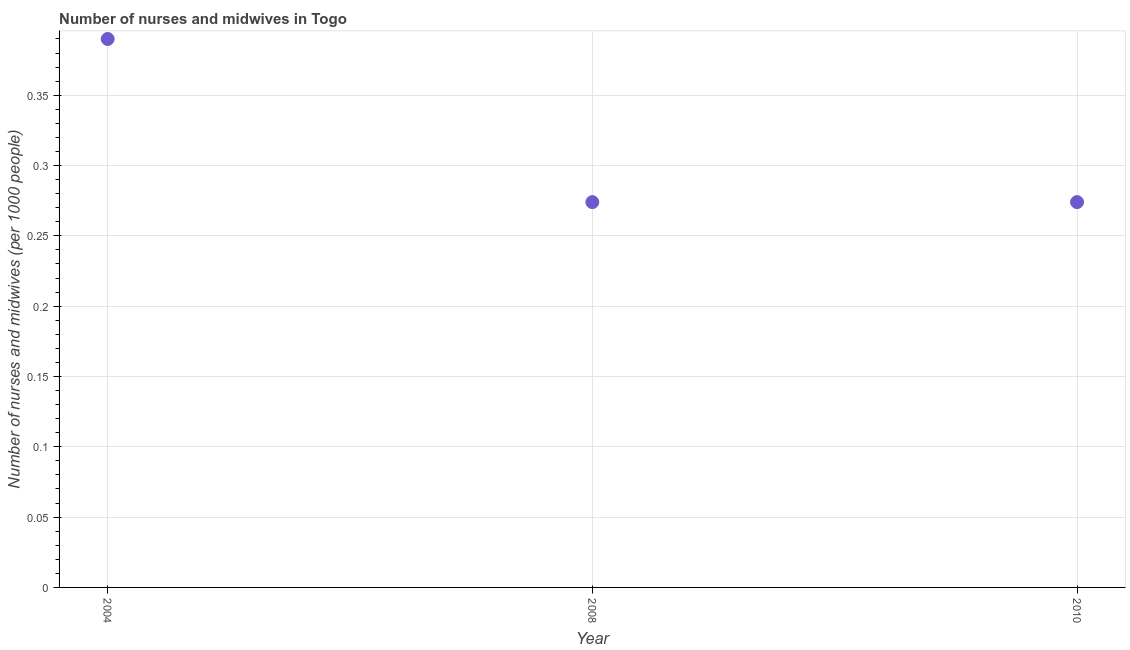What is the number of nurses and midwives in 2010?
Make the answer very short. 0.27. Across all years, what is the maximum number of nurses and midwives?
Keep it short and to the point. 0.39. Across all years, what is the minimum number of nurses and midwives?
Offer a terse response. 0.27. In which year was the number of nurses and midwives minimum?
Offer a terse response. 2008. What is the sum of the number of nurses and midwives?
Offer a very short reply. 0.94. What is the difference between the number of nurses and midwives in 2004 and 2008?
Offer a very short reply. 0.12. What is the average number of nurses and midwives per year?
Make the answer very short. 0.31. What is the median number of nurses and midwives?
Ensure brevity in your answer.  0.27. In how many years, is the number of nurses and midwives greater than 0.07 ?
Provide a short and direct response. 3. Do a majority of the years between 2004 and 2008 (inclusive) have number of nurses and midwives greater than 0.35000000000000003 ?
Ensure brevity in your answer.  No. What is the ratio of the number of nurses and midwives in 2004 to that in 2010?
Your response must be concise. 1.42. Is the number of nurses and midwives in 2004 less than that in 2010?
Make the answer very short. No. Is the difference between the number of nurses and midwives in 2008 and 2010 greater than the difference between any two years?
Your answer should be compact. No. What is the difference between the highest and the second highest number of nurses and midwives?
Make the answer very short. 0.12. What is the difference between the highest and the lowest number of nurses and midwives?
Ensure brevity in your answer.  0.12. What is the difference between two consecutive major ticks on the Y-axis?
Keep it short and to the point. 0.05. Does the graph contain any zero values?
Your answer should be very brief. No. What is the title of the graph?
Make the answer very short. Number of nurses and midwives in Togo. What is the label or title of the X-axis?
Your response must be concise. Year. What is the label or title of the Y-axis?
Offer a terse response. Number of nurses and midwives (per 1000 people). What is the Number of nurses and midwives (per 1000 people) in 2004?
Offer a terse response. 0.39. What is the Number of nurses and midwives (per 1000 people) in 2008?
Give a very brief answer. 0.27. What is the Number of nurses and midwives (per 1000 people) in 2010?
Keep it short and to the point. 0.27. What is the difference between the Number of nurses and midwives (per 1000 people) in 2004 and 2008?
Give a very brief answer. 0.12. What is the difference between the Number of nurses and midwives (per 1000 people) in 2004 and 2010?
Your response must be concise. 0.12. What is the ratio of the Number of nurses and midwives (per 1000 people) in 2004 to that in 2008?
Keep it short and to the point. 1.42. What is the ratio of the Number of nurses and midwives (per 1000 people) in 2004 to that in 2010?
Make the answer very short. 1.42. What is the ratio of the Number of nurses and midwives (per 1000 people) in 2008 to that in 2010?
Provide a short and direct response. 1. 